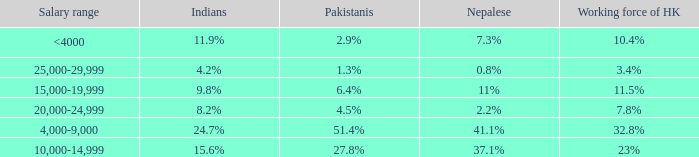If the Indians are 8.2%, what is the salary range? 20,000-24,999. 